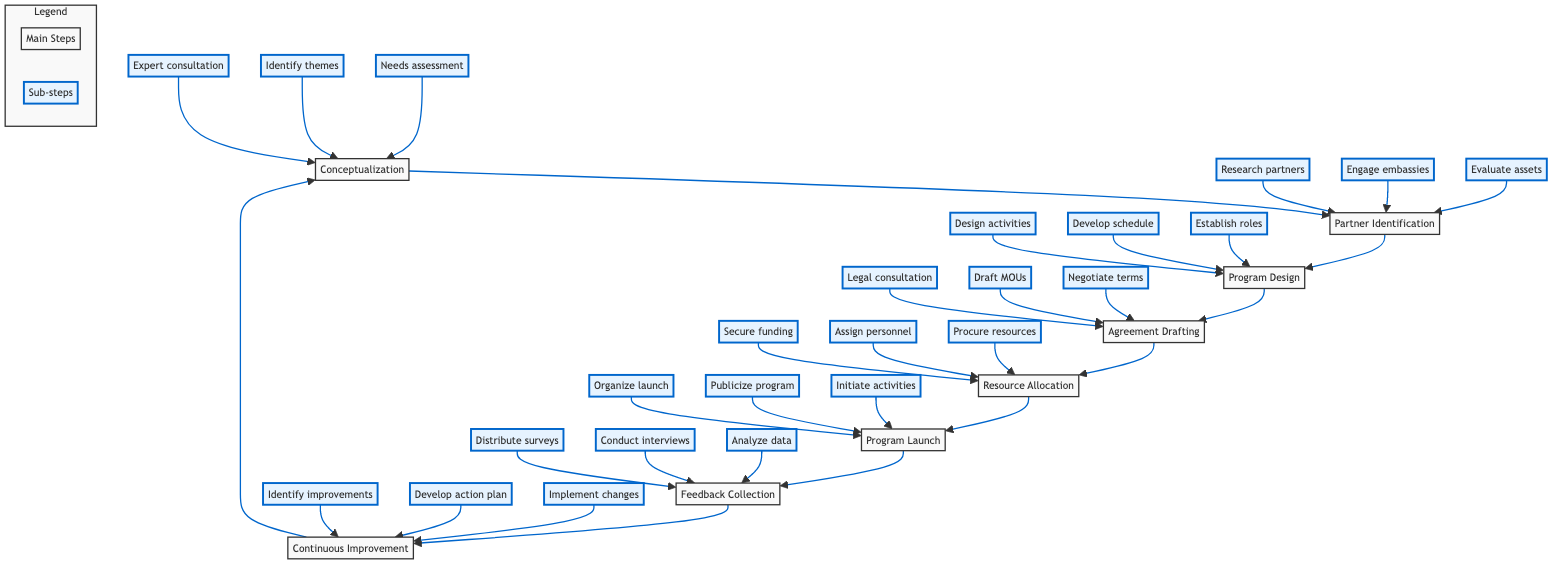What is the first step in the program implementation? The diagram indicates "Conceptualization" as the first step in the flow chart.
Answer: Conceptualization How many main steps are there in the implementation flow? By counting the nodes labeled with main steps, there are eight distinct nodes in the flow chart.
Answer: Eight What follows "Resource Allocation" in the flow of the program? In the sequence outlined in the diagram, "Program Launch" is the next step following "Resource Allocation."
Answer: Program Launch Which sub-step is related to gathering feedback? The sub-step that pertains to gathering feedback is "Distribute feedback surveys." It is one of the activities listed under the "Feedback Collection" step.
Answer: Distribute feedback surveys What is the relationship between "Program Design" and "Agreement Drafting"? The flow chart shows that "Program Design" leads directly to "Agreement Drafting," indicating that after designing the program, the next step is to draft agreements.
Answer: Leads directly to What are the last two steps in the process? The last two steps are "Feedback Collection" and "Continuous Improvement," where feedback is collected and then improvements are made accordingly.
Answer: Feedback Collection and Continuous Improvement What step involves securing funding sources? Securing funding sources is part of the "Resource Allocation" step in the diagram, which details the necessary resources needed for the program.
Answer: Resource Allocation How do improvements get implemented in the program? Improvements are implemented through the "Continuous Improvement" step, which follows the feedback collection phase and addresses identified areas for improvement.
Answer: Continuous Improvement 